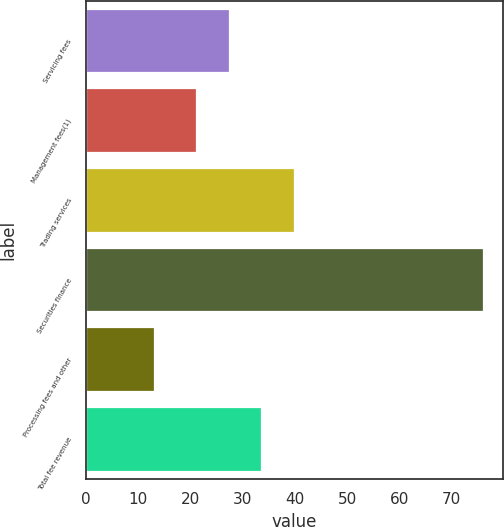<chart> <loc_0><loc_0><loc_500><loc_500><bar_chart><fcel>Servicing fees<fcel>Management fees(1)<fcel>Trading services<fcel>Securities finance<fcel>Processing fees and other<fcel>Total fee revenue<nl><fcel>27.3<fcel>21<fcel>39.9<fcel>76<fcel>13<fcel>33.6<nl></chart> 